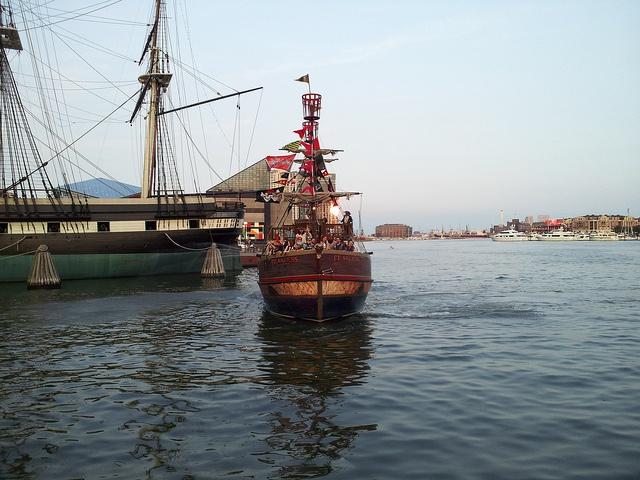Describe the objects in this image and their specific colors. I can see boat in gray, black, and tan tones, boat in gray, black, and maroon tones, boat in gray, ivory, darkgray, and lightgray tones, boat in gray, beige, and darkgray tones, and boat in gray, tan, darkgray, and beige tones in this image. 